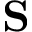Convert formula to latex. <formula><loc_0><loc_0><loc_500><loc_500>S</formula> 